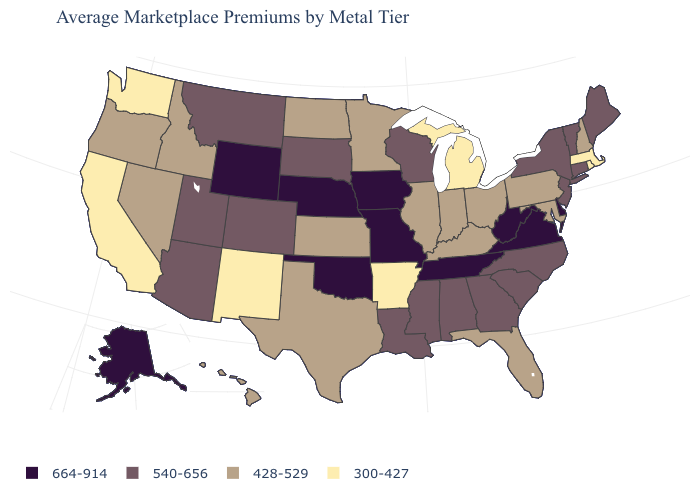Does California have the lowest value in the USA?
Write a very short answer. Yes. Name the states that have a value in the range 300-427?
Short answer required. Arkansas, California, Massachusetts, Michigan, New Mexico, Rhode Island, Washington. What is the value of Nevada?
Be succinct. 428-529. What is the value of Idaho?
Be succinct. 428-529. How many symbols are there in the legend?
Keep it brief. 4. Does Minnesota have the highest value in the MidWest?
Keep it brief. No. What is the value of North Dakota?
Give a very brief answer. 428-529. Does Arkansas have the lowest value in the USA?
Keep it brief. Yes. Among the states that border Illinois , does Indiana have the lowest value?
Quick response, please. Yes. Name the states that have a value in the range 540-656?
Write a very short answer. Alabama, Arizona, Colorado, Connecticut, Georgia, Louisiana, Maine, Mississippi, Montana, New Jersey, New York, North Carolina, South Carolina, South Dakota, Utah, Vermont, Wisconsin. Which states have the lowest value in the West?
Give a very brief answer. California, New Mexico, Washington. What is the lowest value in the USA?
Keep it brief. 300-427. Which states hav the highest value in the MidWest?
Quick response, please. Iowa, Missouri, Nebraska. Name the states that have a value in the range 664-914?
Be succinct. Alaska, Delaware, Iowa, Missouri, Nebraska, Oklahoma, Tennessee, Virginia, West Virginia, Wyoming. What is the lowest value in the USA?
Give a very brief answer. 300-427. 